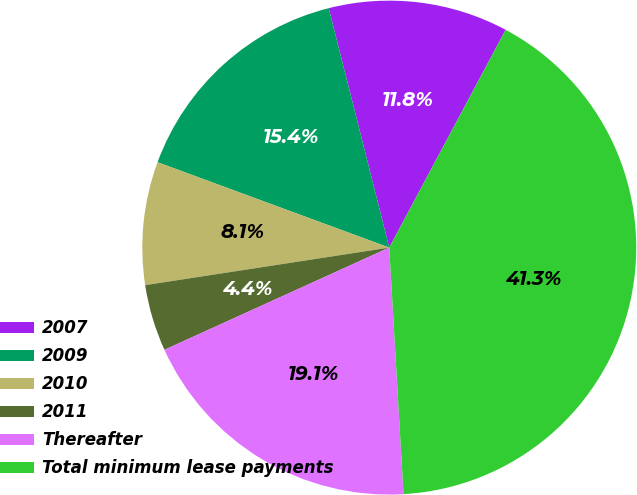Convert chart to OTSL. <chart><loc_0><loc_0><loc_500><loc_500><pie_chart><fcel>2007<fcel>2009<fcel>2010<fcel>2011<fcel>Thereafter<fcel>Total minimum lease payments<nl><fcel>11.75%<fcel>15.44%<fcel>8.05%<fcel>4.36%<fcel>19.13%<fcel>41.27%<nl></chart> 